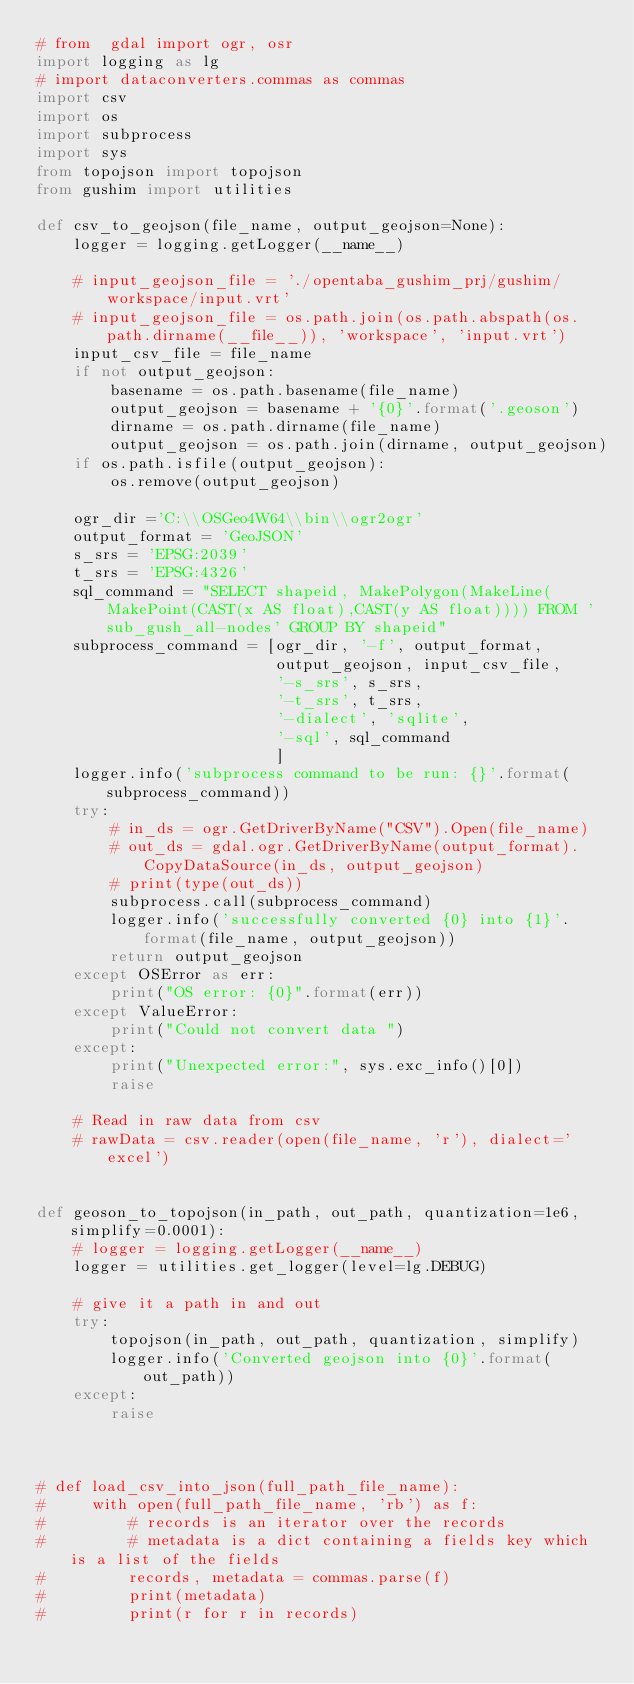<code> <loc_0><loc_0><loc_500><loc_500><_Python_># from  gdal import ogr, osr
import logging as lg
# import dataconverters.commas as commas
import csv
import os
import subprocess
import sys
from topojson import topojson
from gushim import utilities

def csv_to_geojson(file_name, output_geojson=None):
    logger = logging.getLogger(__name__)

    # input_geojson_file = './opentaba_gushim_prj/gushim/workspace/input.vrt'
    # input_geojson_file = os.path.join(os.path.abspath(os.path.dirname(__file__)), 'workspace', 'input.vrt')
    input_csv_file = file_name
    if not output_geojson:
        basename = os.path.basename(file_name)
        output_geojson = basename + '{0}'.format('.geoson')
        dirname = os.path.dirname(file_name)
        output_geojson = os.path.join(dirname, output_geojson)
    if os.path.isfile(output_geojson):
        os.remove(output_geojson)

    ogr_dir ='C:\\OSGeo4W64\\bin\\ogr2ogr'
    output_format = 'GeoJSON'
    s_srs = 'EPSG:2039'
    t_srs = 'EPSG:4326'
    sql_command = "SELECT shapeid, MakePolygon(MakeLine(MakePoint(CAST(x AS float),CAST(y AS float)))) FROM 'sub_gush_all-nodes' GROUP BY shapeid"
    subprocess_command = [ogr_dir, '-f', output_format,
                          output_geojson, input_csv_file,
                          '-s_srs', s_srs,
                          '-t_srs', t_srs,
                          '-dialect', 'sqlite',
                          '-sql', sql_command
                          ]
    logger.info('subprocess command to be run: {}'.format(subprocess_command))
    try:
        # in_ds = ogr.GetDriverByName("CSV").Open(file_name)
        # out_ds = gdal.ogr.GetDriverByName(output_format).CopyDataSource(in_ds, output_geojson)
        # print(type(out_ds))
        subprocess.call(subprocess_command)
        logger.info('successfully converted {0} into {1}'.format(file_name, output_geojson))
        return output_geojson
    except OSError as err:
        print("OS error: {0}".format(err))
    except ValueError:
        print("Could not convert data ")
    except:
        print("Unexpected error:", sys.exc_info()[0])
        raise

    # Read in raw data from csv
    # rawData = csv.reader(open(file_name, 'r'), dialect='excel')


def geoson_to_topojson(in_path, out_path, quantization=1e6, simplify=0.0001):
    # logger = logging.getLogger(__name__)
    logger = utilities.get_logger(level=lg.DEBUG)

    # give it a path in and out
    try:
        topojson(in_path, out_path, quantization, simplify)
        logger.info('Converted geojson into {0}'.format(out_path))
    except:
        raise



# def load_csv_into_json(full_path_file_name):
#     with open(full_path_file_name, 'rb') as f:
#         # records is an iterator over the records
#         # metadata is a dict containing a fields key which is a list of the fields
#         records, metadata = commas.parse(f)
#         print(metadata)
#         print(r for r in records)



</code> 